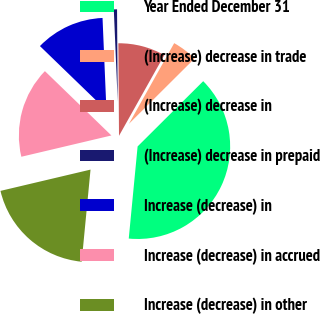<chart> <loc_0><loc_0><loc_500><loc_500><pie_chart><fcel>Year Ended December 31<fcel>(Increase) decrease in trade<fcel>(Increase) decrease in<fcel>(Increase) decrease in prepaid<fcel>Increase (decrease) in<fcel>Increase (decrease) in accrued<fcel>Increase (decrease) in other<nl><fcel>38.99%<fcel>4.4%<fcel>8.25%<fcel>0.56%<fcel>12.09%<fcel>15.93%<fcel>19.78%<nl></chart> 